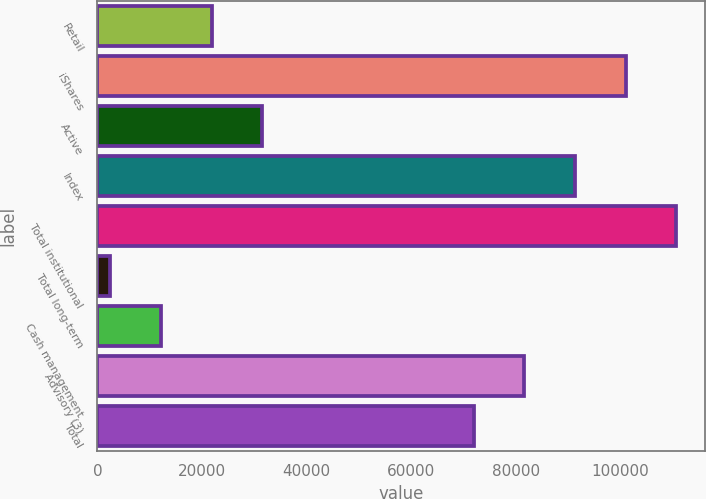<chart> <loc_0><loc_0><loc_500><loc_500><bar_chart><fcel>Retail<fcel>iShares<fcel>Active<fcel>Index<fcel>Total institutional<fcel>Total long-term<fcel>Cash management<fcel>Advisory (3)<fcel>Total<nl><fcel>21809.6<fcel>100974<fcel>31481.9<fcel>91301.6<fcel>110646<fcel>2465<fcel>12137.3<fcel>81629.3<fcel>71957<nl></chart> 